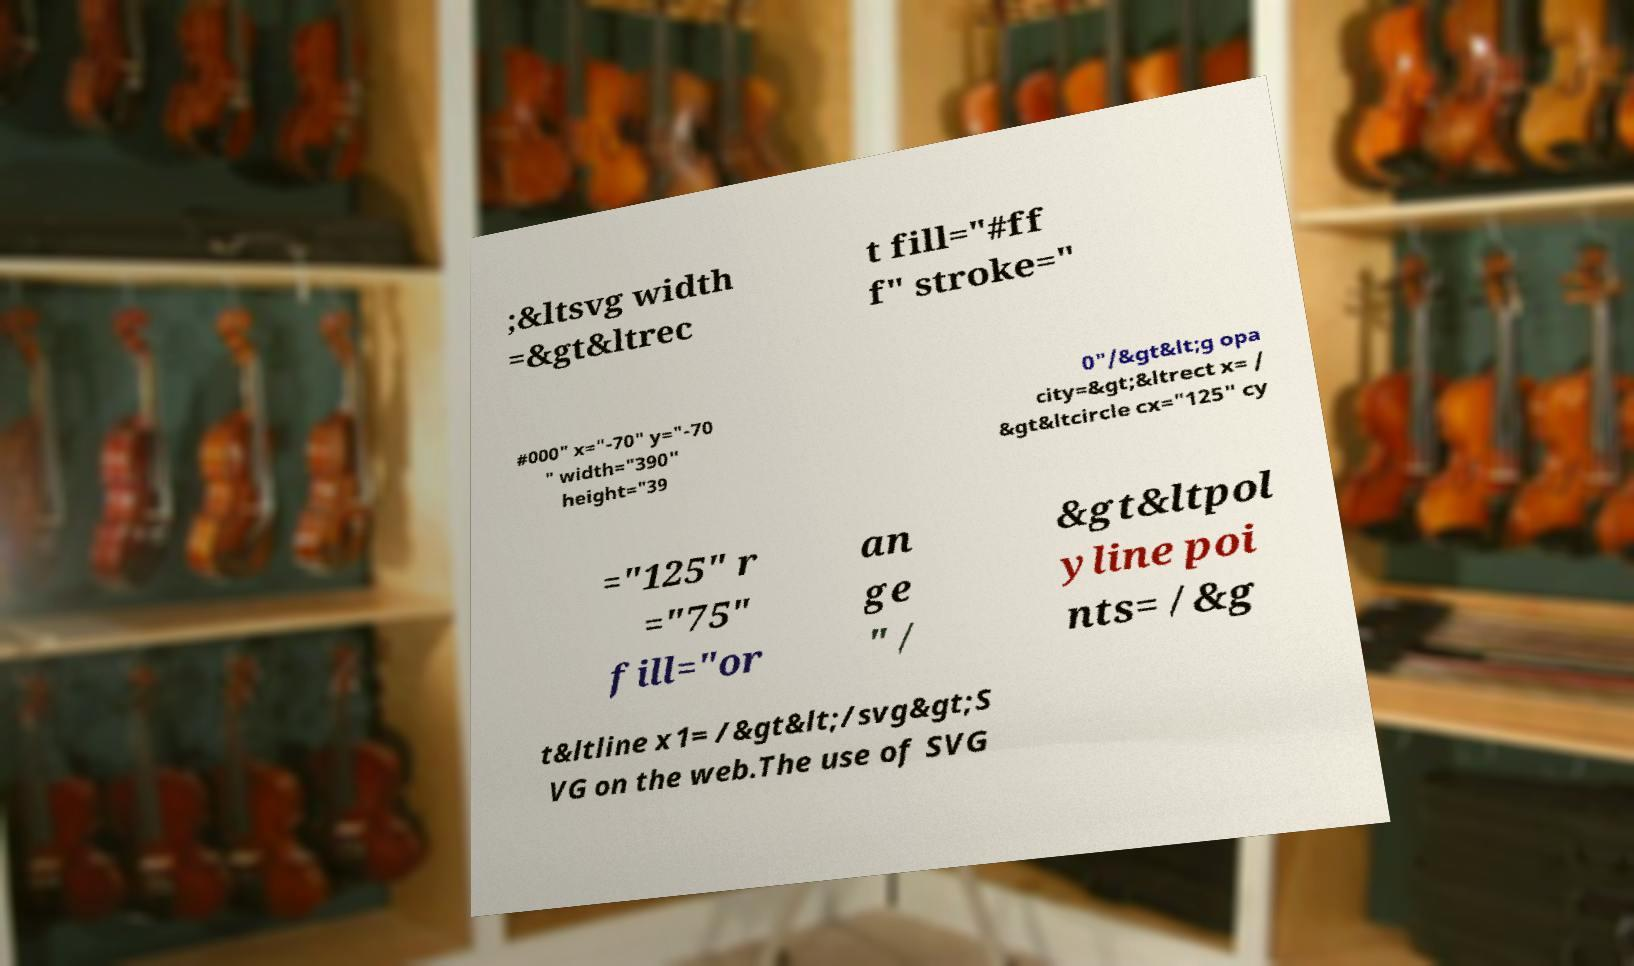Can you accurately transcribe the text from the provided image for me? ;&ltsvg width =&gt&ltrec t fill="#ff f" stroke=" #000" x="-70" y="-70 " width="390" height="39 0"/&gt&lt;g opa city=&gt;&ltrect x= / &gt&ltcircle cx="125" cy ="125" r ="75" fill="or an ge " / &gt&ltpol yline poi nts= /&g t&ltline x1= /&gt&lt;/svg&gt;S VG on the web.The use of SVG 